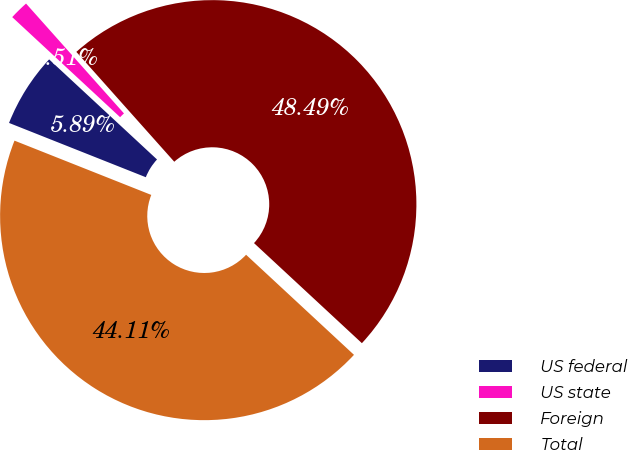<chart> <loc_0><loc_0><loc_500><loc_500><pie_chart><fcel>US federal<fcel>US state<fcel>Foreign<fcel>Total<nl><fcel>5.89%<fcel>1.51%<fcel>48.49%<fcel>44.11%<nl></chart> 